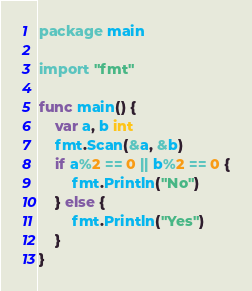Convert code to text. <code><loc_0><loc_0><loc_500><loc_500><_Go_>package main

import "fmt"

func main() {
	var a, b int
	fmt.Scan(&a, &b)
	if a%2 == 0 || b%2 == 0 {
		fmt.Println("No")
	} else {
		fmt.Println("Yes")
	}
}
</code> 